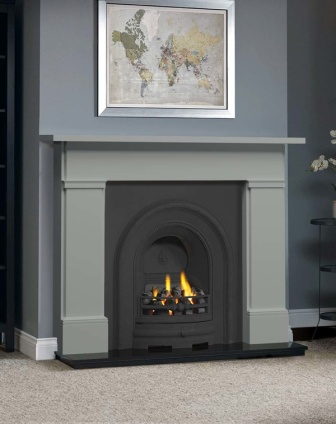Explain the visual content of the image in great detail.
 The image presents a cozy living room scene centered around a gray fireplace. The fireplace, with its gray mantel and black firebox, houses a lively fire, casting a warm glow in the room. Above the fireplace, a white framed painting adds an artistic touch to the gray wall. 

To the right of the fireplace, a black shelf stands, hosting a single plant, adding a touch of greenery to the room. The hardwood floor beneath is partially covered by a gray rug, placed right in front of the fireplace, perhaps to provide a comfortable spot to enjoy the warmth of the fire. 

The room is devoid of any text or discernible human activity, leaving the lit fireplace as the main focus of the scene. The relative positions of the objects suggest a well-organized and thoughtfully designed space. The fireplace, painting, shelf, and plant all align vertically, creating a balanced composition. 

This description is based on the visible elements in the image and does not include any speculative or imaginary content. 